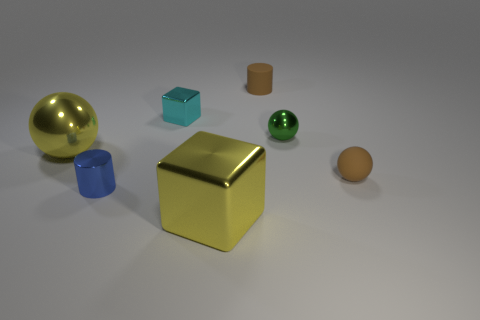Subtract all metallic spheres. How many spheres are left? 1 Add 3 rubber objects. How many objects exist? 10 Subtract all brown balls. How many balls are left? 2 Subtract all gray spheres. How many blue cylinders are left? 1 Subtract all tiny red metallic blocks. Subtract all small brown cylinders. How many objects are left? 6 Add 2 tiny blue cylinders. How many tiny blue cylinders are left? 3 Add 7 small green balls. How many small green balls exist? 8 Subtract 1 yellow blocks. How many objects are left? 6 Subtract all blocks. How many objects are left? 5 Subtract 1 cylinders. How many cylinders are left? 1 